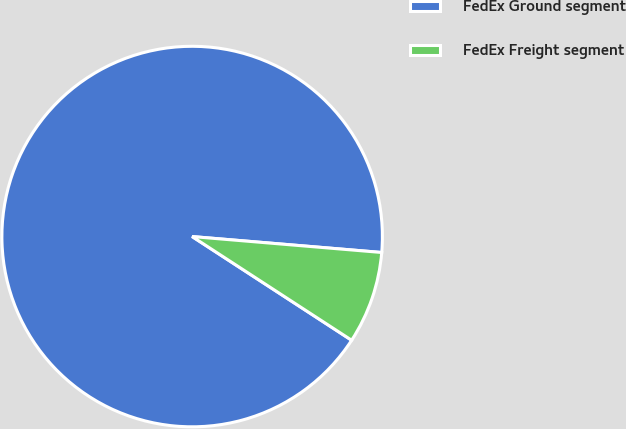Convert chart. <chart><loc_0><loc_0><loc_500><loc_500><pie_chart><fcel>FedEx Ground segment<fcel>FedEx Freight segment<nl><fcel>92.16%<fcel>7.84%<nl></chart> 